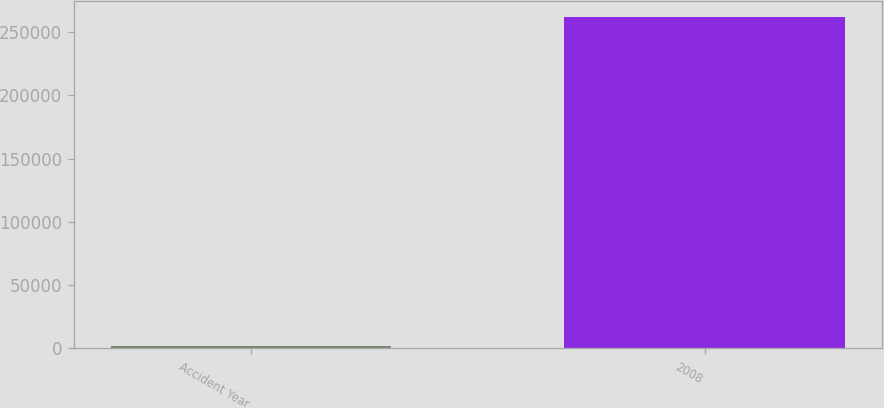Convert chart to OTSL. <chart><loc_0><loc_0><loc_500><loc_500><bar_chart><fcel>Accident Year<fcel>2008<nl><fcel>2010<fcel>261867<nl></chart> 